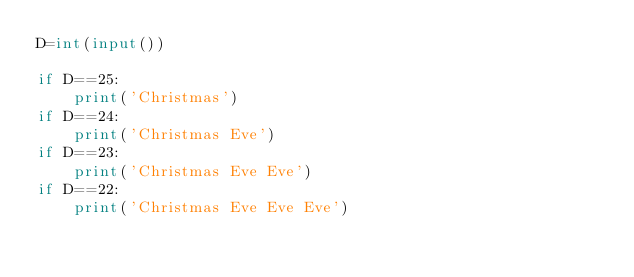<code> <loc_0><loc_0><loc_500><loc_500><_Python_>D=int(input())

if D==25:
    print('Christmas')
if D==24:
    print('Christmas Eve')
if D==23:
    print('Christmas Eve Eve')
if D==22:
    print('Christmas Eve Eve Eve')
    </code> 